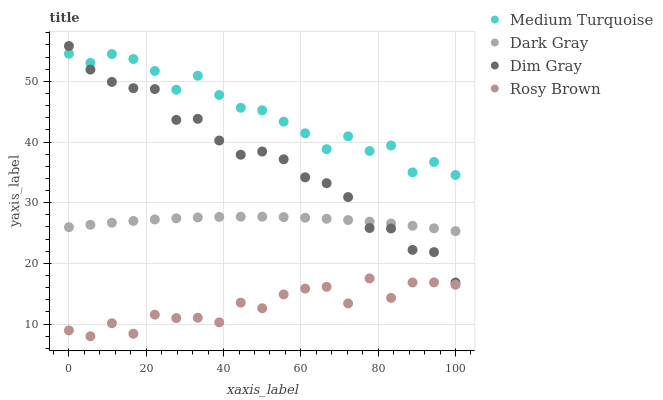Does Rosy Brown have the minimum area under the curve?
Answer yes or no. Yes. Does Medium Turquoise have the maximum area under the curve?
Answer yes or no. Yes. Does Dim Gray have the minimum area under the curve?
Answer yes or no. No. Does Dim Gray have the maximum area under the curve?
Answer yes or no. No. Is Dark Gray the smoothest?
Answer yes or no. Yes. Is Rosy Brown the roughest?
Answer yes or no. Yes. Is Dim Gray the smoothest?
Answer yes or no. No. Is Dim Gray the roughest?
Answer yes or no. No. Does Rosy Brown have the lowest value?
Answer yes or no. Yes. Does Dim Gray have the lowest value?
Answer yes or no. No. Does Dim Gray have the highest value?
Answer yes or no. Yes. Does Rosy Brown have the highest value?
Answer yes or no. No. Is Dark Gray less than Medium Turquoise?
Answer yes or no. Yes. Is Medium Turquoise greater than Rosy Brown?
Answer yes or no. Yes. Does Dim Gray intersect Medium Turquoise?
Answer yes or no. Yes. Is Dim Gray less than Medium Turquoise?
Answer yes or no. No. Is Dim Gray greater than Medium Turquoise?
Answer yes or no. No. Does Dark Gray intersect Medium Turquoise?
Answer yes or no. No. 